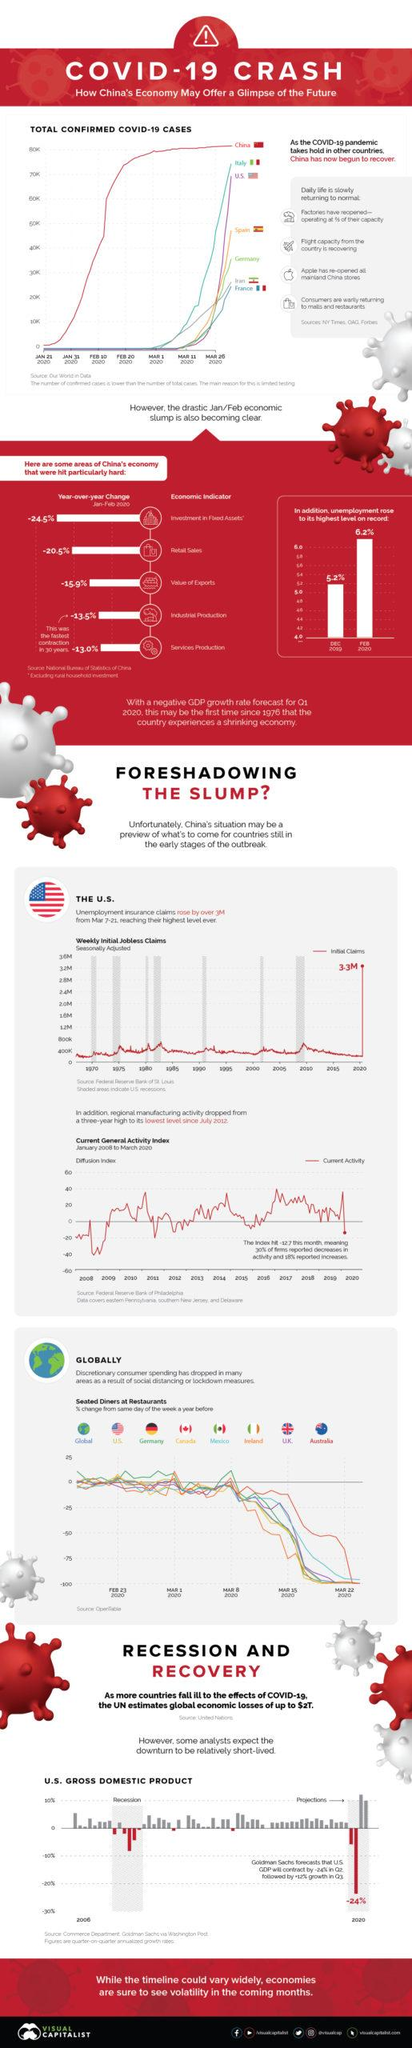Give some essential details in this illustration. The unemployment rate in February was 1% higher than in December. 